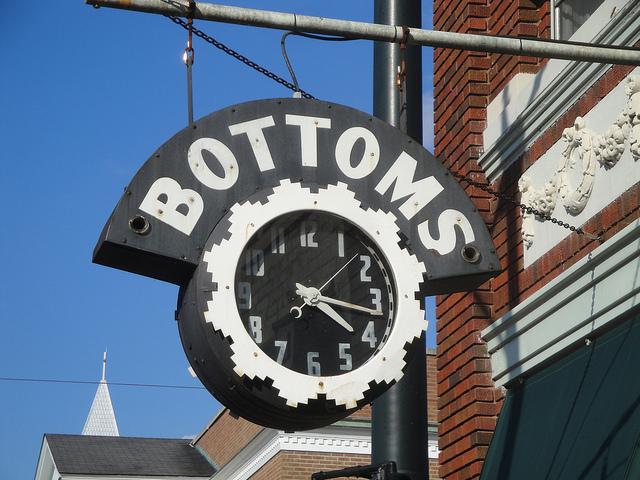What time is it?
Give a very brief answer. 4:17. Is water seen on the background?
Answer briefly. No. Is the clock hanging on a pole?
Keep it brief. Yes. What is the name above the clock?
Keep it brief. Bottoms. Whose lodge is this?
Give a very brief answer. Bottoms. 